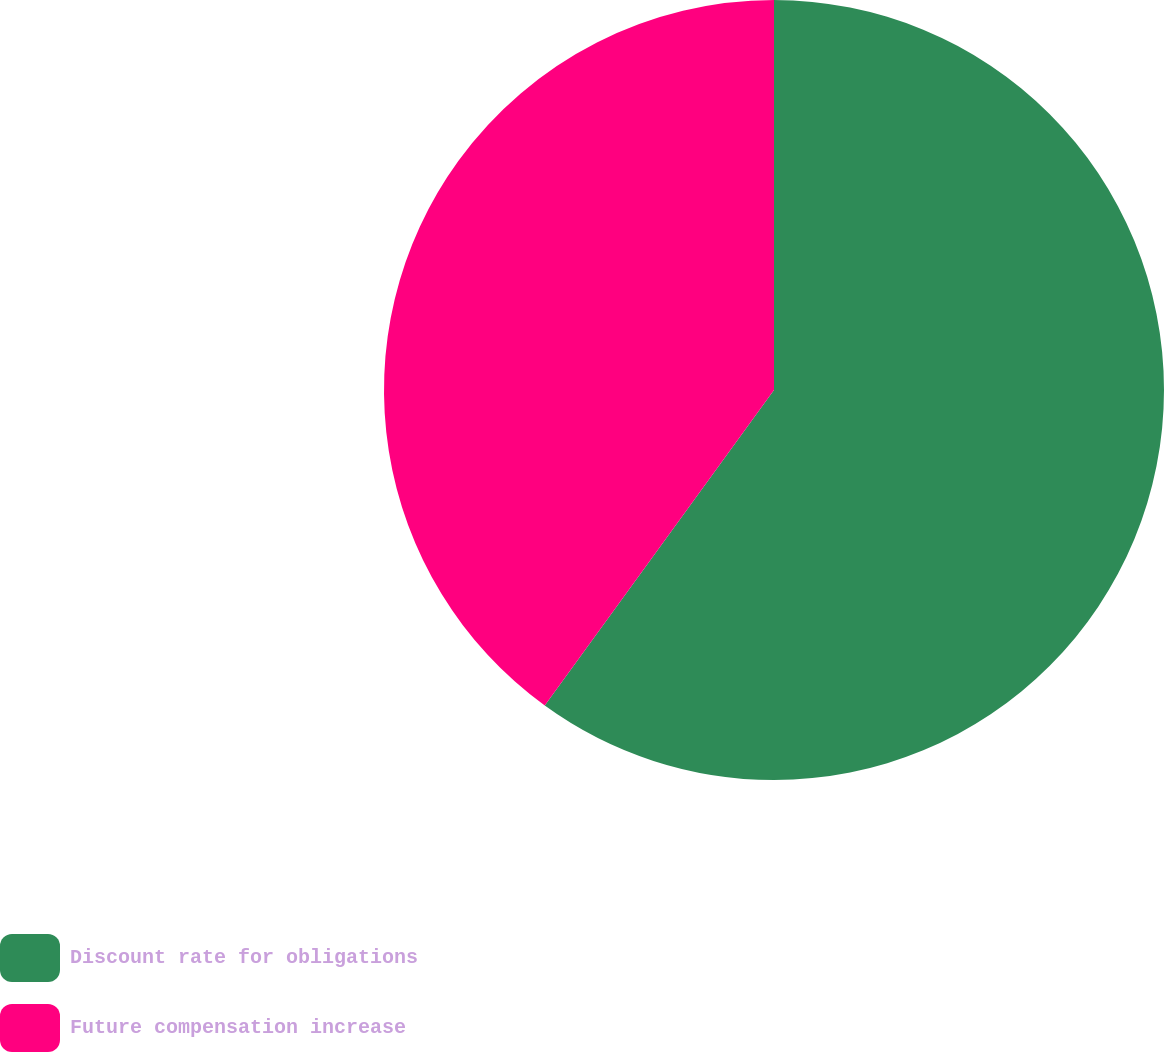Convert chart to OTSL. <chart><loc_0><loc_0><loc_500><loc_500><pie_chart><fcel>Discount rate for obligations<fcel>Future compensation increase<nl><fcel>60.0%<fcel>40.0%<nl></chart> 